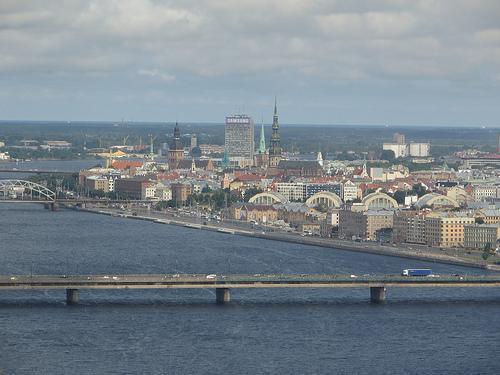How many trucks on the bridge?
Give a very brief answer. 1. 